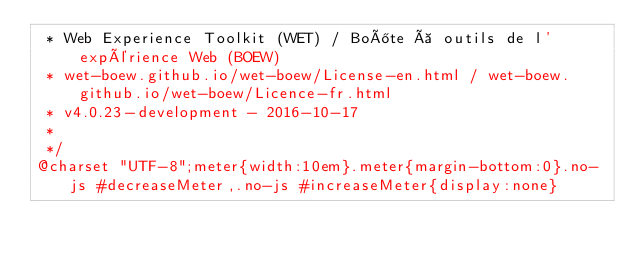<code> <loc_0><loc_0><loc_500><loc_500><_CSS_> * Web Experience Toolkit (WET) / Boîte à outils de l'expérience Web (BOEW)
 * wet-boew.github.io/wet-boew/License-en.html / wet-boew.github.io/wet-boew/Licence-fr.html
 * v4.0.23-development - 2016-10-17
 *
 */
@charset "UTF-8";meter{width:10em}.meter{margin-bottom:0}.no-js #decreaseMeter,.no-js #increaseMeter{display:none}</code> 